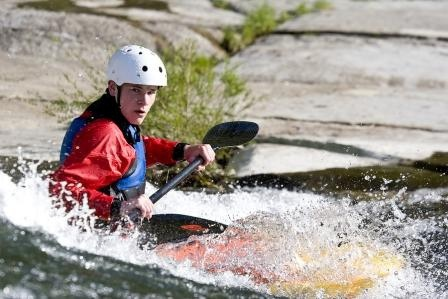Describe the objects in this image and their specific colors. I can see people in darkgray, black, maroon, white, and gray tones and boat in darkgray, black, gray, maroon, and brown tones in this image. 